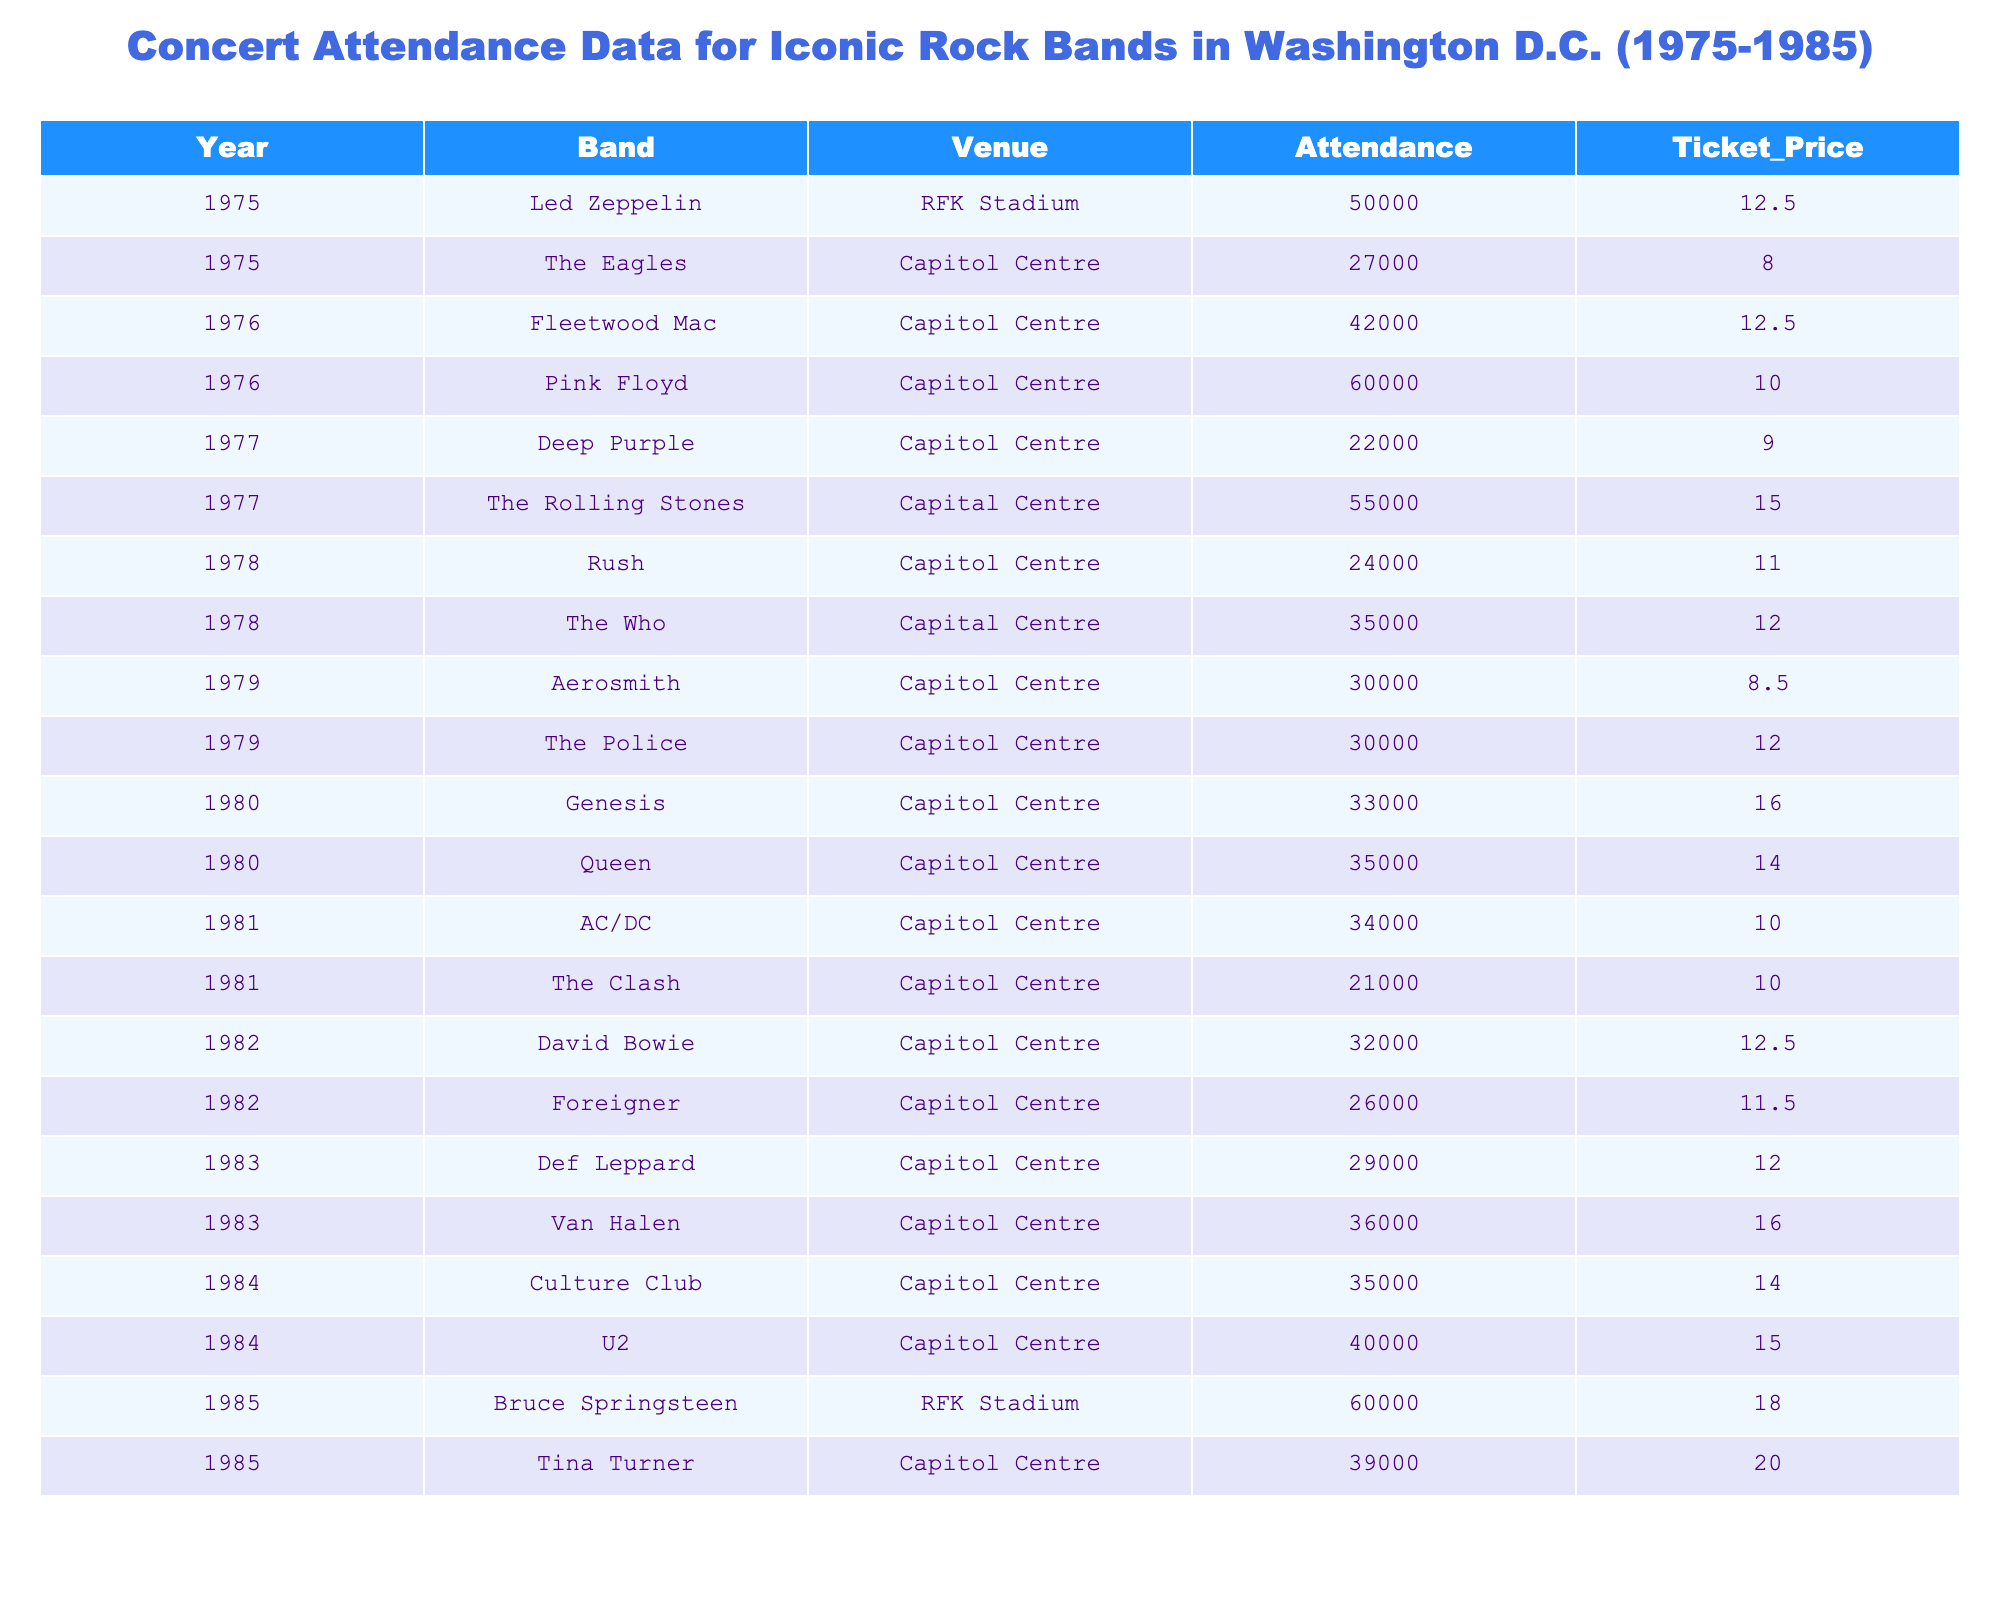What's the highest attendance recorded in the table? The highest attendance is found in the row for Led Zeppelin in 1975, which shows an attendance figure of 50,000.
Answer: 60000 Which band had the lowest attendance? By reviewing the attendance figures in the table, Deep Purple in 1977 shows the lowest attendance number of 22,000.
Answer: 22000 What was the average ticket price for all concerts listed? To find the average ticket price, sum all the ticket prices (12.50 + 10 + 15 + 12 + 8.50 + 14 + 10 + 12.50 + 16 + 15 + 18 + 8 + 12.50 + 9 + 11 + 12 + 10 + 11.50 + 12 + 14 + 20 = 238) and divide by the total number of concerts (20). This gives an average ticket price of 11.90.
Answer: 11.90 How many times did the Capitol Centre host concerts in total? Counting the rows where the Venue is "Capitol Centre" in the table gives 16 occurrences.
Answer: 16 What was the difference in attendance between the concerts of Bruce Springsteen and The Eagles in 1985? The attendance for Bruce Springsteen in 1985 is 60,000 and for The Eagles in 1975 is 27,000. The difference is calculated as 60,000 - 27,000, which equals 33,000.
Answer: 33000 Which band performed at the highest ticket price, and what was that price? The highest ticket price is from Tina Turner in 1985, who had a ticket price of 20.00.
Answer: 20.00 Did the attendance for Queen in 1980 exceed that of The Who in 1978? The attendance for Queen in 1980 is 35,000, while The Who in 1978 had an attendance of 35,000. Since Queen's attendance did not exceed, the answer is no.
Answer: No What percentage of the total attendance was from Pink Floyd's concert in 1976? First, sum the total attendance for all concerts, which is 513,000. Pink Floyd's attendance was 60,000. To find the percentage: (60,000 / 513,000) * 100 = 11.7%.
Answer: 11.7% How many distinct bands performed in 1985? In 1985, there were two concerts listed: one by Bruce Springsteen and one by Tina Turner, meaning two distinct bands performed that year.
Answer: 2 